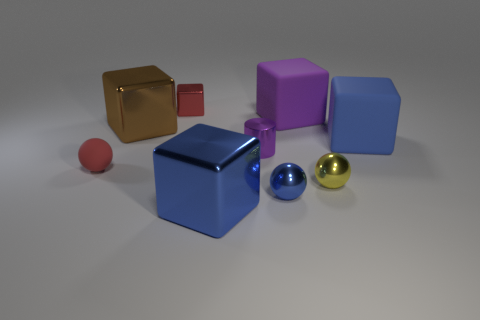Subtract all tiny yellow balls. How many balls are left? 2 Add 1 small yellow shiny cubes. How many objects exist? 10 Subtract all balls. How many objects are left? 6 Subtract 1 cylinders. How many cylinders are left? 0 Subtract all gray spheres. How many red cylinders are left? 0 Subtract all tiny purple rubber spheres. Subtract all purple rubber blocks. How many objects are left? 8 Add 7 big blue objects. How many big blue objects are left? 9 Add 4 tiny rubber spheres. How many tiny rubber spheres exist? 5 Subtract all red balls. How many balls are left? 2 Subtract 0 yellow cylinders. How many objects are left? 9 